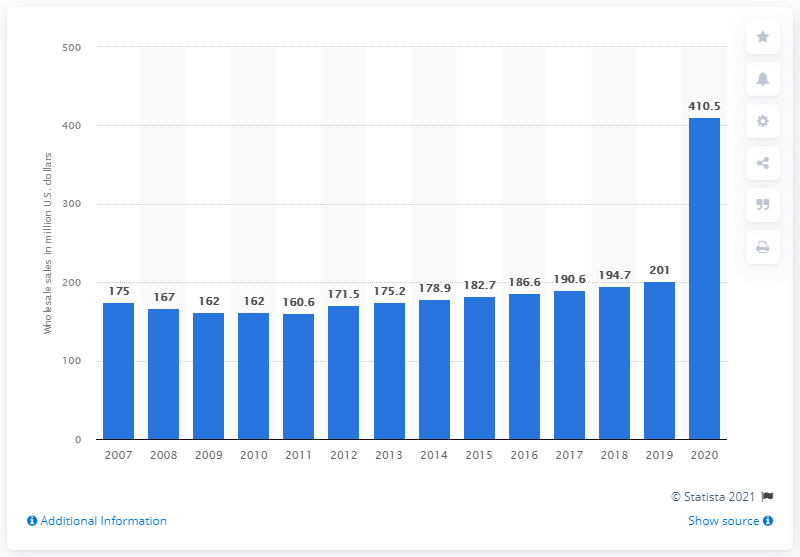Indicate a few pertinent items in this graphic. In 2020, the wholesale sales of free weights in the United States totaled 410.5 million dollars. 